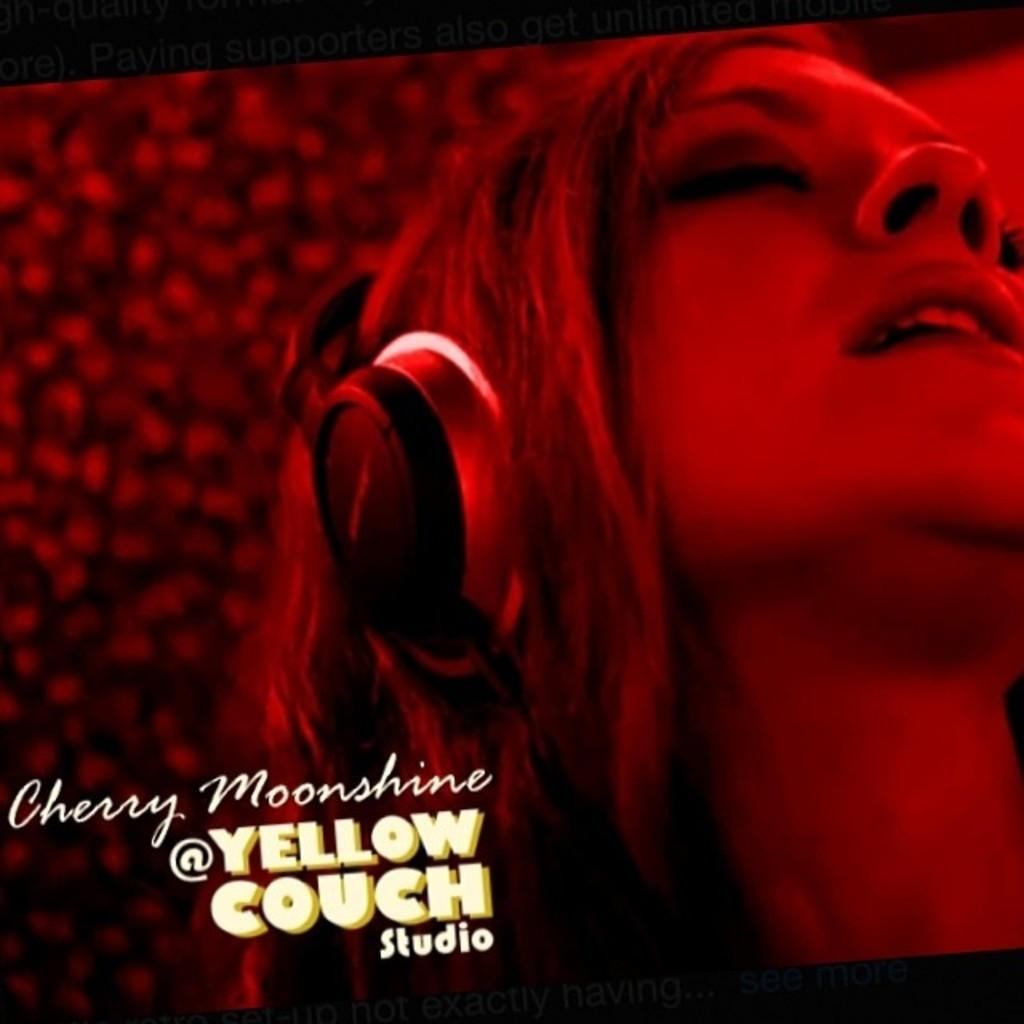What is the main subject of the poster in the image? The main subject of the poster in the image is a woman wearing headsets. What color is the background of the poster? The background of the poster is red in color. What can be found at the bottom of the poster? There is text at the bottom of the poster. What type of fiction is the woman in the poster reading? There is no indication of the woman reading any fiction in the image; she is wearing headsets. How many birds are in the flock depicted on the poster? There is no flock of birds depicted on the poster; it features a woman wearing headsets against a red background with text at the bottom. 